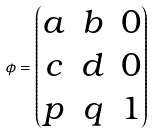<formula> <loc_0><loc_0><loc_500><loc_500>\phi = \begin{pmatrix} a & b & 0 \\ c & d & 0 \\ p & q & 1 \end{pmatrix}</formula> 